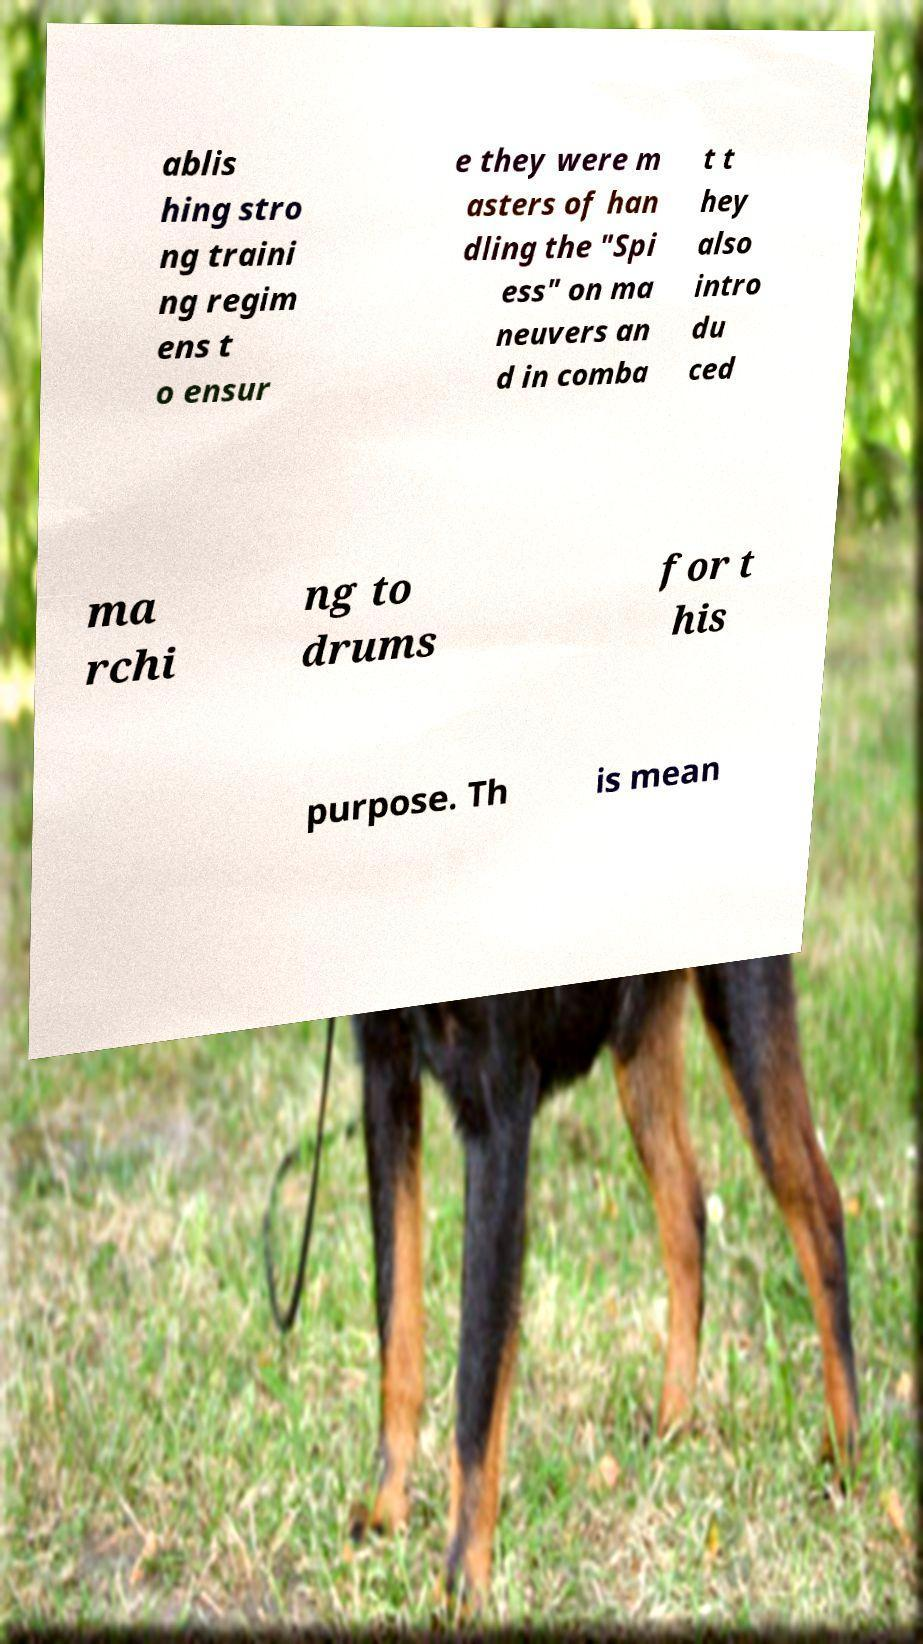Please read and relay the text visible in this image. What does it say? ablis hing stro ng traini ng regim ens t o ensur e they were m asters of han dling the "Spi ess" on ma neuvers an d in comba t t hey also intro du ced ma rchi ng to drums for t his purpose. Th is mean 